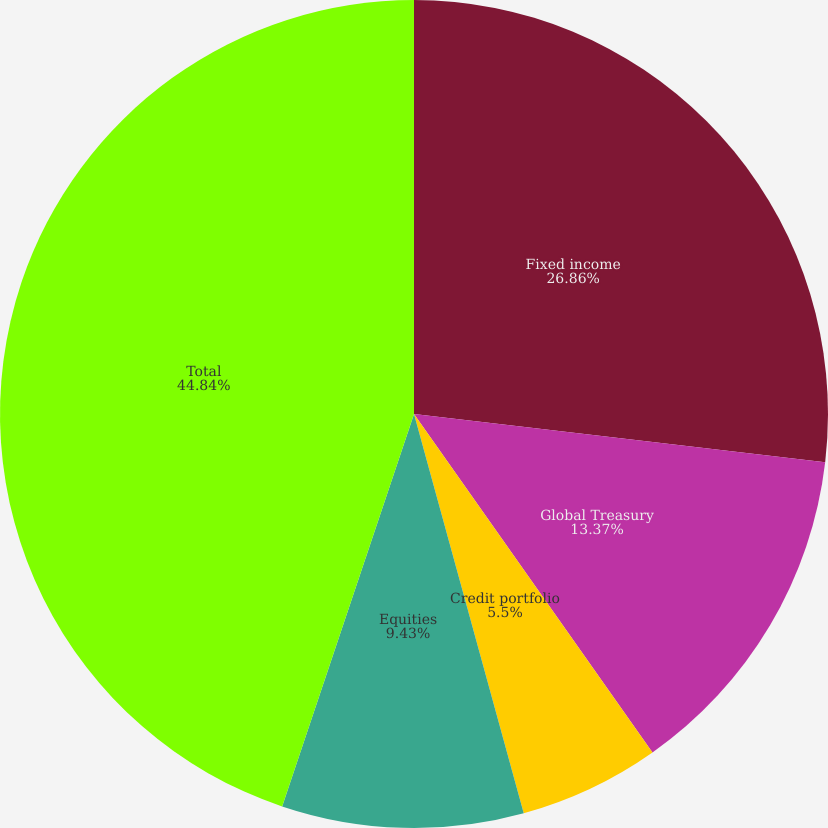<chart> <loc_0><loc_0><loc_500><loc_500><pie_chart><fcel>Fixed income<fcel>Global Treasury<fcel>Credit portfolio<fcel>Equities<fcel>Total<nl><fcel>26.86%<fcel>13.37%<fcel>5.5%<fcel>9.43%<fcel>44.84%<nl></chart> 